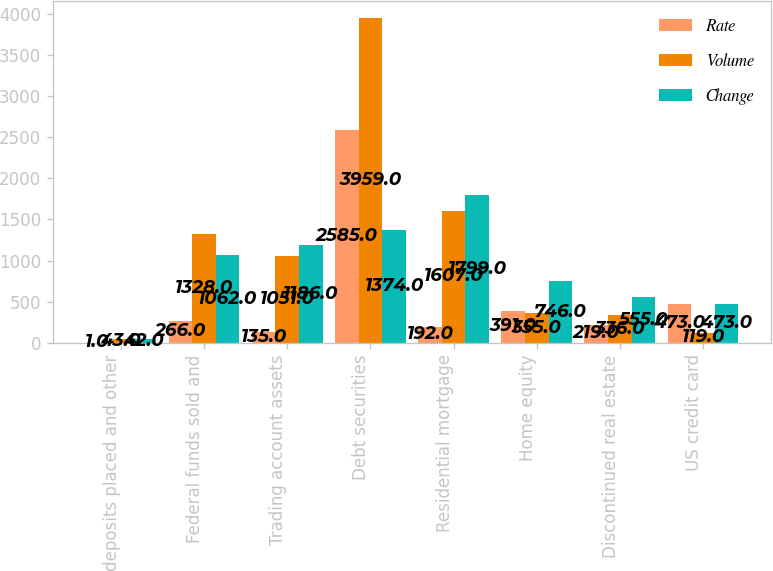Convert chart to OTSL. <chart><loc_0><loc_0><loc_500><loc_500><stacked_bar_chart><ecel><fcel>Time deposits placed and other<fcel>Federal funds sold and<fcel>Trading account assets<fcel>Debt securities<fcel>Residential mortgage<fcel>Home equity<fcel>Discontinued real estate<fcel>US credit card<nl><fcel>Rate<fcel>1<fcel>266<fcel>135<fcel>2585<fcel>192<fcel>391<fcel>219<fcel>473<nl><fcel>Volume<fcel>43<fcel>1328<fcel>1051<fcel>3959<fcel>1607<fcel>355<fcel>336<fcel>119<nl><fcel>Change<fcel>42<fcel>1062<fcel>1186<fcel>1374<fcel>1799<fcel>746<fcel>555<fcel>473<nl></chart> 